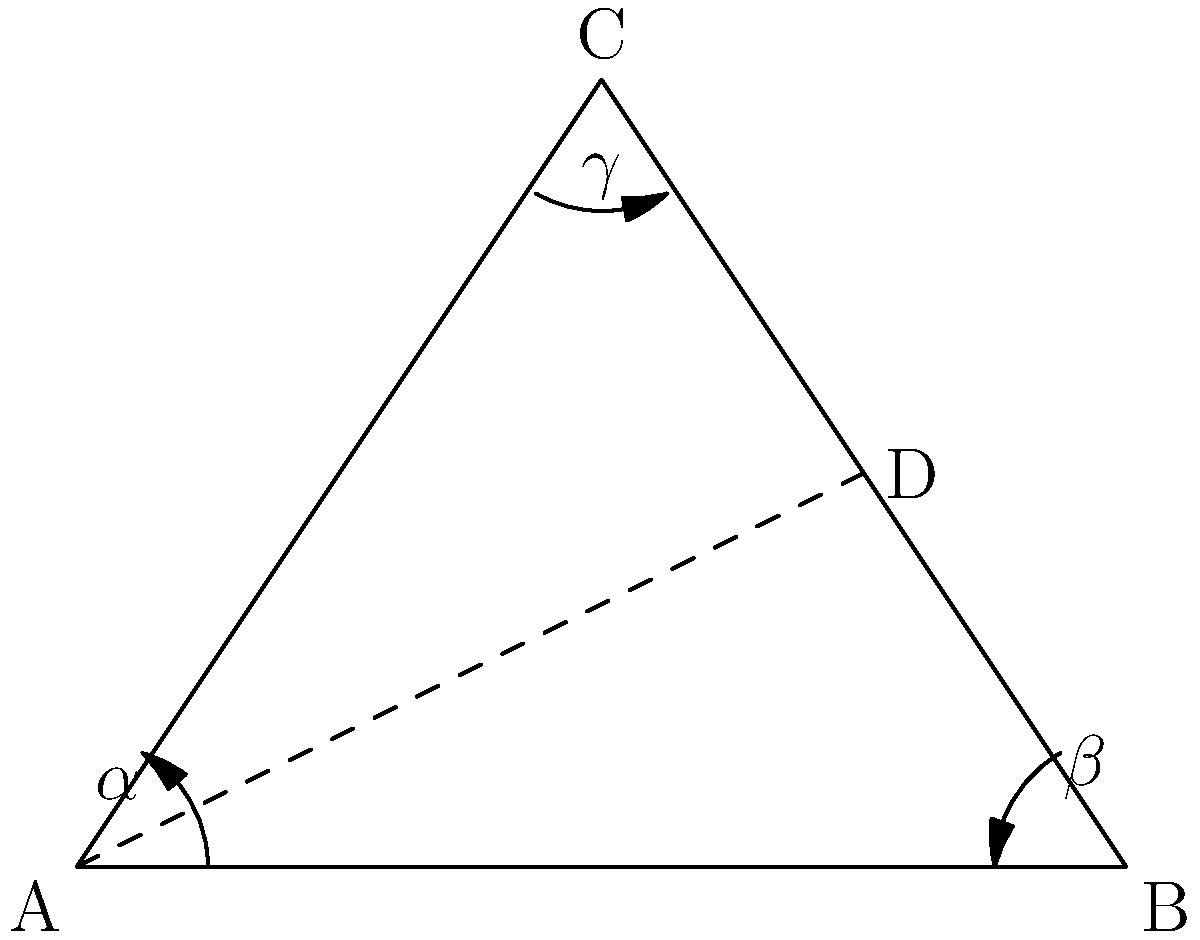In a triangular formation of directional antennas, three antennas are placed at the vertices A, B, and C of an isosceles triangle ABC. The optimal coverage is achieved when the antennas are oriented such that their beam directions bisect the angles of the triangle. If the base angles of the isosceles triangle (at A and B) are each $60°$, what is the optimal angle $\gamma$ for the antenna at vertex C? Let's approach this step-by-step:

1) In an isosceles triangle, the base angles are equal. We're given that these angles (at A and B) are $60°$ each.

2) The sum of angles in a triangle is always $180°$. So we can find the angle at C:
   $$180° - (60° + 60°) = 60°$$

3) The angle at C is also $60°$, which means this is actually an equilateral triangle.

4) In an equilateral triangle, all angles are equal and measure $60°$.

5) The question states that the optimal orientation for each antenna is to bisect the angle of the triangle at its vertex.

6) To bisect means to divide into two equal parts. So the optimal angle $\gamma$ for the antenna at C would be half of the angle at C:
   $$\gamma = 60° ÷ 2 = 30°$$

Therefore, the optimal angle for the antenna at vertex C is $30°$.
Answer: $30°$ 